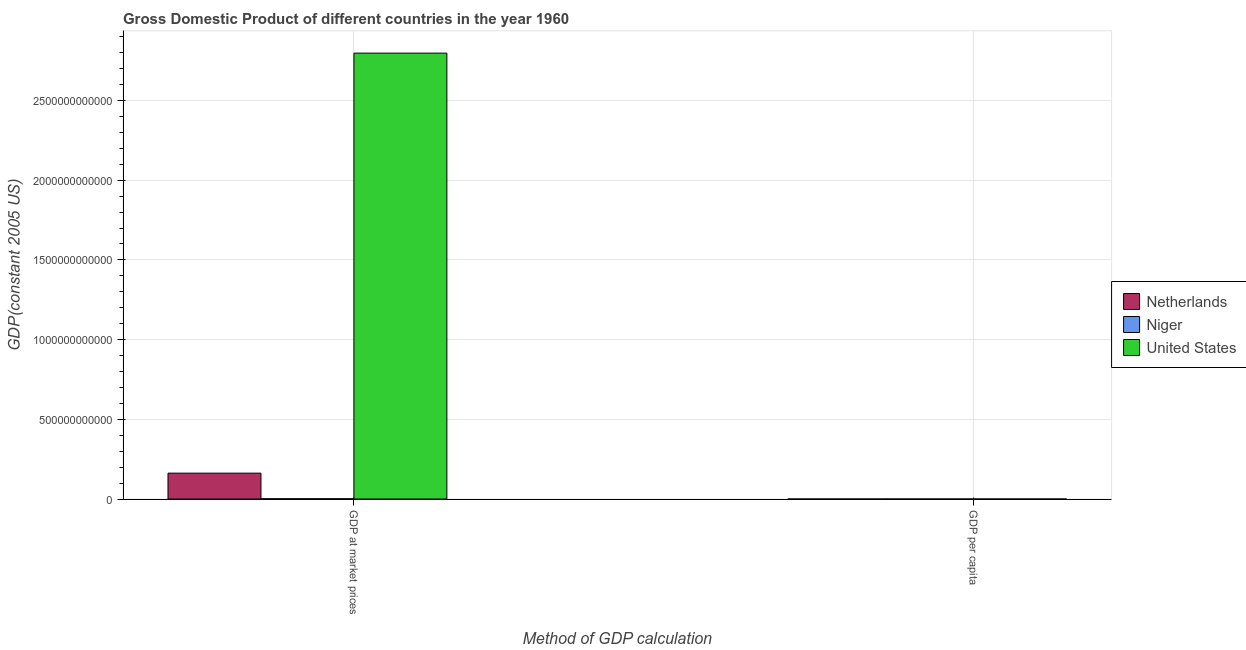How many different coloured bars are there?
Keep it short and to the point. 3. How many groups of bars are there?
Make the answer very short. 2. Are the number of bars per tick equal to the number of legend labels?
Keep it short and to the point. Yes. Are the number of bars on each tick of the X-axis equal?
Give a very brief answer. Yes. How many bars are there on the 1st tick from the left?
Provide a short and direct response. 3. How many bars are there on the 2nd tick from the right?
Provide a succinct answer. 3. What is the label of the 1st group of bars from the left?
Your response must be concise. GDP at market prices. What is the gdp per capita in Netherlands?
Make the answer very short. 1.41e+04. Across all countries, what is the maximum gdp per capita?
Offer a terse response. 1.55e+04. Across all countries, what is the minimum gdp per capita?
Offer a very short reply. 468.22. In which country was the gdp at market prices maximum?
Give a very brief answer. United States. In which country was the gdp at market prices minimum?
Offer a terse response. Niger. What is the total gdp per capita in the graph?
Your response must be concise. 3.01e+04. What is the difference between the gdp at market prices in United States and that in Netherlands?
Offer a very short reply. 2.63e+12. What is the difference between the gdp per capita in United States and the gdp at market prices in Niger?
Your response must be concise. -1.59e+09. What is the average gdp at market prices per country?
Give a very brief answer. 9.87e+11. What is the difference between the gdp per capita and gdp at market prices in United States?
Offer a terse response. -2.80e+12. What is the ratio of the gdp at market prices in Niger to that in United States?
Offer a very short reply. 0. In how many countries, is the gdp per capita greater than the average gdp per capita taken over all countries?
Offer a terse response. 2. What does the 3rd bar from the right in GDP per capita represents?
Your response must be concise. Netherlands. How many bars are there?
Ensure brevity in your answer.  6. What is the difference between two consecutive major ticks on the Y-axis?
Provide a succinct answer. 5.00e+11. Are the values on the major ticks of Y-axis written in scientific E-notation?
Offer a very short reply. No. Does the graph contain any zero values?
Make the answer very short. No. Does the graph contain grids?
Your answer should be very brief. Yes. What is the title of the graph?
Provide a succinct answer. Gross Domestic Product of different countries in the year 1960. What is the label or title of the X-axis?
Provide a short and direct response. Method of GDP calculation. What is the label or title of the Y-axis?
Your answer should be very brief. GDP(constant 2005 US). What is the GDP(constant 2005 US) in Netherlands in GDP at market prices?
Your answer should be compact. 1.62e+11. What is the GDP(constant 2005 US) of Niger in GDP at market prices?
Offer a terse response. 1.59e+09. What is the GDP(constant 2005 US) of United States in GDP at market prices?
Provide a short and direct response. 2.80e+12. What is the GDP(constant 2005 US) of Netherlands in GDP per capita?
Provide a succinct answer. 1.41e+04. What is the GDP(constant 2005 US) of Niger in GDP per capita?
Your answer should be compact. 468.22. What is the GDP(constant 2005 US) in United States in GDP per capita?
Provide a succinct answer. 1.55e+04. Across all Method of GDP calculation, what is the maximum GDP(constant 2005 US) of Netherlands?
Give a very brief answer. 1.62e+11. Across all Method of GDP calculation, what is the maximum GDP(constant 2005 US) in Niger?
Your answer should be very brief. 1.59e+09. Across all Method of GDP calculation, what is the maximum GDP(constant 2005 US) of United States?
Your answer should be very brief. 2.80e+12. Across all Method of GDP calculation, what is the minimum GDP(constant 2005 US) of Netherlands?
Offer a very short reply. 1.41e+04. Across all Method of GDP calculation, what is the minimum GDP(constant 2005 US) in Niger?
Your response must be concise. 468.22. Across all Method of GDP calculation, what is the minimum GDP(constant 2005 US) of United States?
Make the answer very short. 1.55e+04. What is the total GDP(constant 2005 US) of Netherlands in the graph?
Provide a succinct answer. 1.62e+11. What is the total GDP(constant 2005 US) of Niger in the graph?
Keep it short and to the point. 1.59e+09. What is the total GDP(constant 2005 US) of United States in the graph?
Make the answer very short. 2.80e+12. What is the difference between the GDP(constant 2005 US) in Netherlands in GDP at market prices and that in GDP per capita?
Your answer should be compact. 1.62e+11. What is the difference between the GDP(constant 2005 US) of Niger in GDP at market prices and that in GDP per capita?
Offer a terse response. 1.59e+09. What is the difference between the GDP(constant 2005 US) of United States in GDP at market prices and that in GDP per capita?
Provide a succinct answer. 2.80e+12. What is the difference between the GDP(constant 2005 US) in Netherlands in GDP at market prices and the GDP(constant 2005 US) in Niger in GDP per capita?
Keep it short and to the point. 1.62e+11. What is the difference between the GDP(constant 2005 US) in Netherlands in GDP at market prices and the GDP(constant 2005 US) in United States in GDP per capita?
Provide a succinct answer. 1.62e+11. What is the difference between the GDP(constant 2005 US) in Niger in GDP at market prices and the GDP(constant 2005 US) in United States in GDP per capita?
Your response must be concise. 1.59e+09. What is the average GDP(constant 2005 US) in Netherlands per Method of GDP calculation?
Ensure brevity in your answer.  8.12e+1. What is the average GDP(constant 2005 US) of Niger per Method of GDP calculation?
Your answer should be very brief. 7.95e+08. What is the average GDP(constant 2005 US) in United States per Method of GDP calculation?
Your answer should be very brief. 1.40e+12. What is the difference between the GDP(constant 2005 US) of Netherlands and GDP(constant 2005 US) of Niger in GDP at market prices?
Offer a very short reply. 1.61e+11. What is the difference between the GDP(constant 2005 US) of Netherlands and GDP(constant 2005 US) of United States in GDP at market prices?
Provide a short and direct response. -2.63e+12. What is the difference between the GDP(constant 2005 US) of Niger and GDP(constant 2005 US) of United States in GDP at market prices?
Offer a terse response. -2.80e+12. What is the difference between the GDP(constant 2005 US) in Netherlands and GDP(constant 2005 US) in Niger in GDP per capita?
Give a very brief answer. 1.37e+04. What is the difference between the GDP(constant 2005 US) in Netherlands and GDP(constant 2005 US) in United States in GDP per capita?
Offer a very short reply. -1348.24. What is the difference between the GDP(constant 2005 US) in Niger and GDP(constant 2005 US) in United States in GDP per capita?
Your answer should be very brief. -1.50e+04. What is the ratio of the GDP(constant 2005 US) of Netherlands in GDP at market prices to that in GDP per capita?
Your answer should be compact. 1.15e+07. What is the ratio of the GDP(constant 2005 US) in Niger in GDP at market prices to that in GDP per capita?
Your response must be concise. 3.40e+06. What is the ratio of the GDP(constant 2005 US) in United States in GDP at market prices to that in GDP per capita?
Your answer should be very brief. 1.81e+08. What is the difference between the highest and the second highest GDP(constant 2005 US) of Netherlands?
Provide a short and direct response. 1.62e+11. What is the difference between the highest and the second highest GDP(constant 2005 US) of Niger?
Offer a very short reply. 1.59e+09. What is the difference between the highest and the second highest GDP(constant 2005 US) of United States?
Keep it short and to the point. 2.80e+12. What is the difference between the highest and the lowest GDP(constant 2005 US) in Netherlands?
Your answer should be compact. 1.62e+11. What is the difference between the highest and the lowest GDP(constant 2005 US) in Niger?
Provide a short and direct response. 1.59e+09. What is the difference between the highest and the lowest GDP(constant 2005 US) of United States?
Offer a terse response. 2.80e+12. 